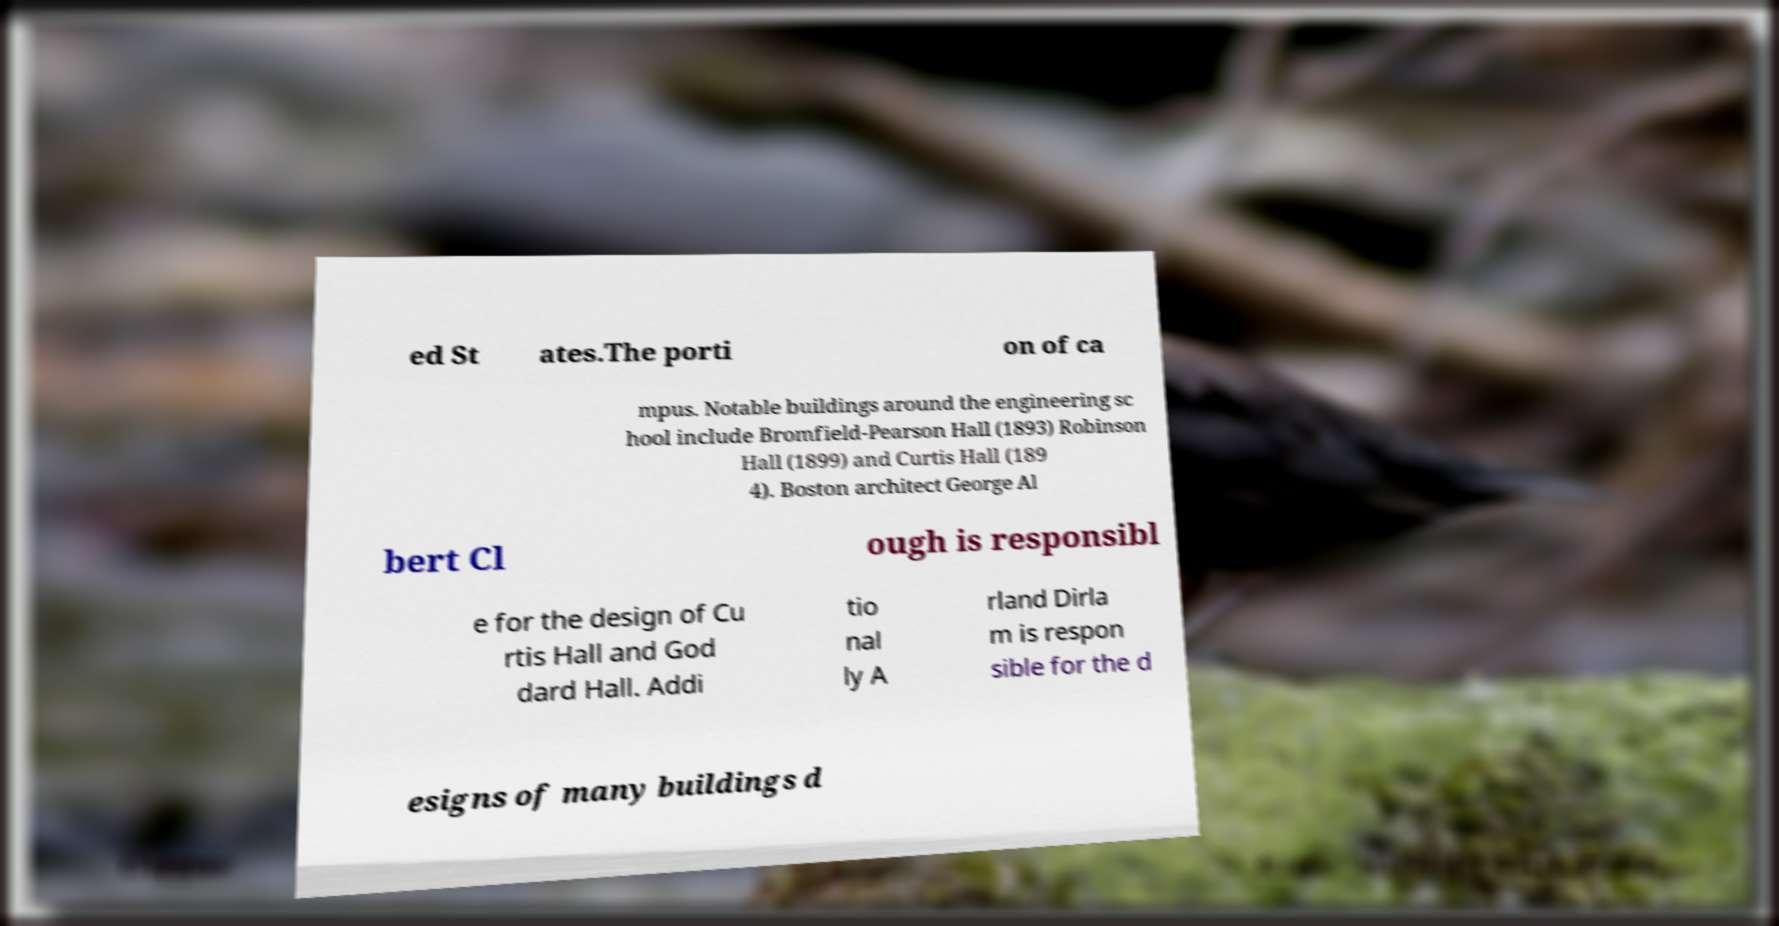Please read and relay the text visible in this image. What does it say? ed St ates.The porti on of ca mpus. Notable buildings around the engineering sc hool include Bromfield-Pearson Hall (1893) Robinson Hall (1899) and Curtis Hall (189 4). Boston architect George Al bert Cl ough is responsibl e for the design of Cu rtis Hall and God dard Hall. Addi tio nal ly A rland Dirla m is respon sible for the d esigns of many buildings d 